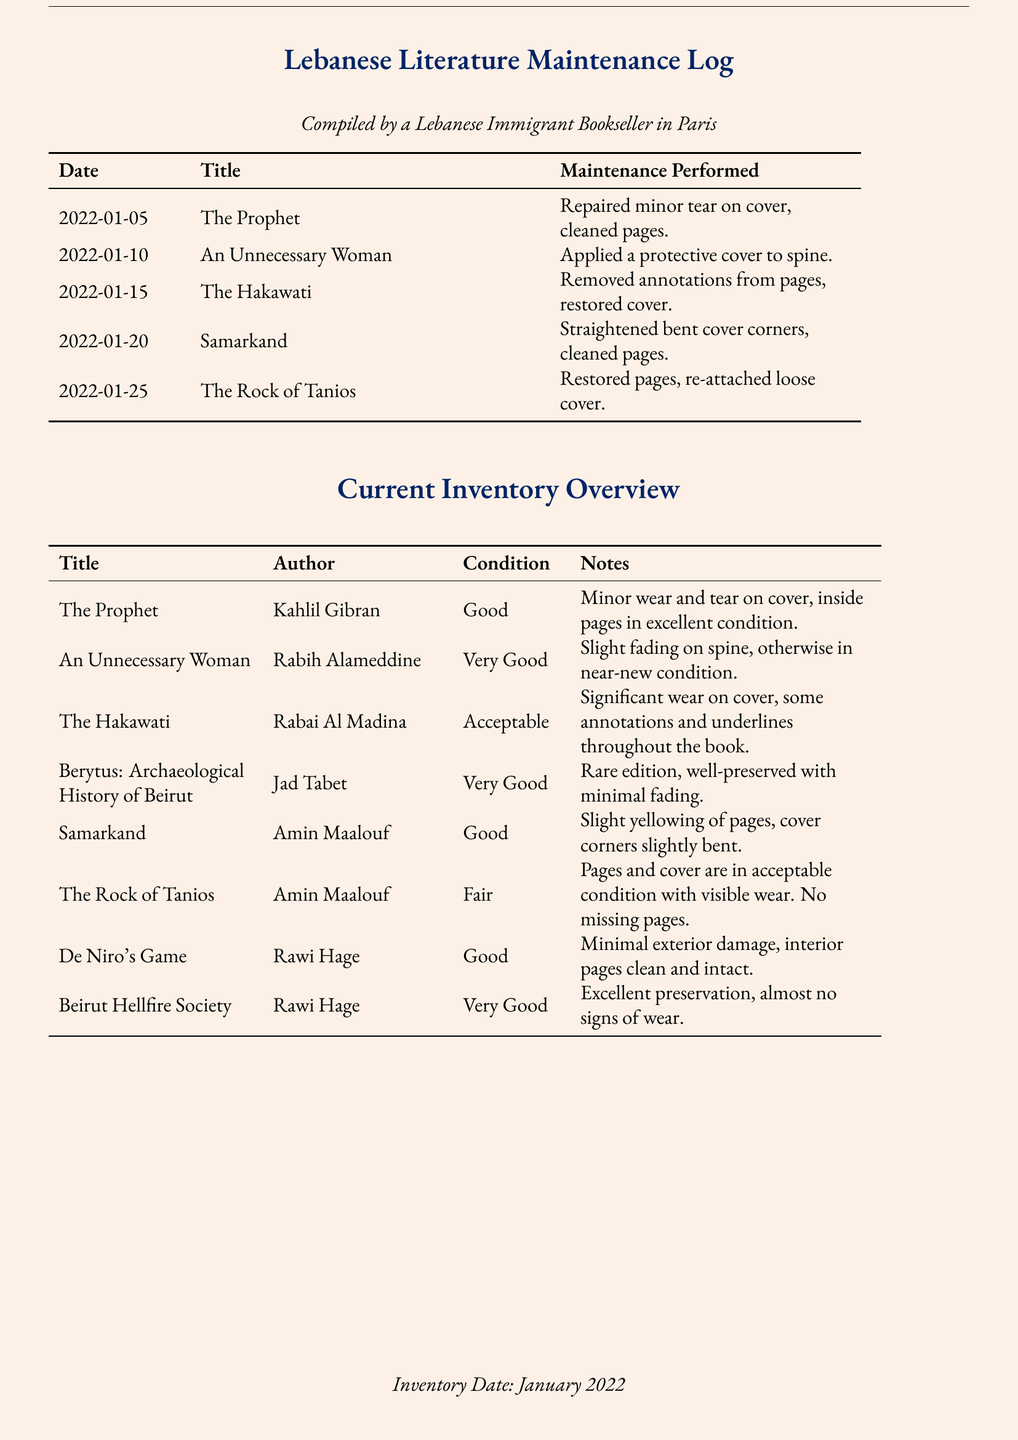What is the title of the book repaired on January 5th? The title of the book is mentioned in the date-specific maintenance section of the document.
Answer: The Prophet Who is the author of "An Unnecessary Woman"? The author is listed in the inventory overview for that particular title.
Answer: Rabih Alameddine What is the condition of "The Hakawati"? The condition is provided in the inventory overview section of the document, detailing the state of the book.
Answer: Acceptable How many books were repaired in total? The maintenance log lists each book that received repairs, allowing for a count.
Answer: Five What maintenance was performed on "Samarkand"? The specific actions taken for book maintenance can be found in the maintenance log.
Answer: Straightened bent cover corners, cleaned pages Which book has a note of 'almost no signs of wear'? The notes for each book provide additional detail about their condition, which includes this phrase.
Answer: Beirut Hellfire Society What is the date of the inventory? The inventory date is stated clearly at the bottom of the document.
Answer: January 2022 Which book is described as a 'Rare edition'? The notes regarding each book contain descriptors that identify specific characteristics.
Answer: Berytus: Archaeological History of Beirut What type of restoration was performed on "The Rock of Tanios"? The maintenance actions taken are detailed in the maintenance log section.
Answer: Restored pages, re-attached loose cover 